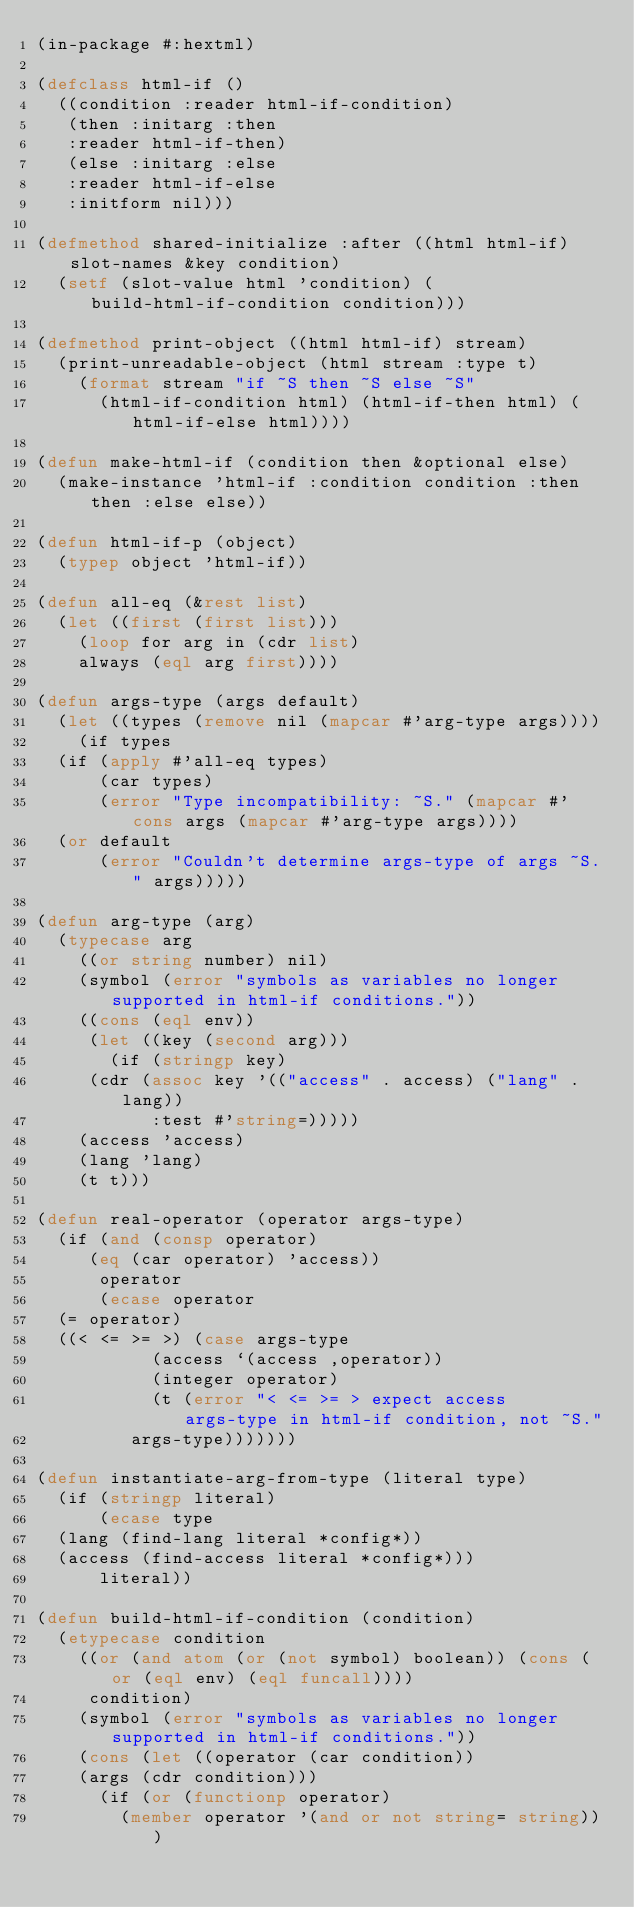<code> <loc_0><loc_0><loc_500><loc_500><_Lisp_>(in-package #:hextml)

(defclass html-if ()
  ((condition :reader html-if-condition)
   (then :initarg :then
	 :reader html-if-then)
   (else :initarg :else
	 :reader html-if-else
	 :initform nil)))

(defmethod shared-initialize :after ((html html-if) slot-names &key condition)
  (setf (slot-value html 'condition) (build-html-if-condition condition)))

(defmethod print-object ((html html-if) stream)
  (print-unreadable-object (html stream :type t)
    (format stream "if ~S then ~S else ~S"
	    (html-if-condition html) (html-if-then html) (html-if-else html))))

(defun make-html-if (condition then &optional else)
  (make-instance 'html-if :condition condition :then then :else else))

(defun html-if-p (object)
  (typep object 'html-if))

(defun all-eq (&rest list)
  (let ((first (first list)))
    (loop for arg in (cdr list)
	  always (eql arg first))))

(defun args-type (args default)
  (let ((types (remove nil (mapcar #'arg-type args))))
    (if types
	(if (apply #'all-eq types)
	    (car types)
	    (error "Type incompatibility: ~S." (mapcar #'cons args (mapcar #'arg-type args))))
	(or default
	    (error "Couldn't determine args-type of args ~S." args)))))

(defun arg-type (arg)
  (typecase arg
    ((or string number) nil)
    (symbol (error "symbols as variables no longer supported in html-if conditions."))
    ((cons (eql env))
     (let ((key (second arg)))
       (if (stringp key)
	   (cdr (assoc key '(("access" . access) ("lang" . lang))
		       :test #'string=)))))
    (access 'access)
    (lang 'lang)
    (t t)))

(defun real-operator (operator args-type)
  (if (and (consp operator)
	   (eq (car operator) 'access))
      operator
      (ecase operator
	(= operator)
	((< <= >= >) (case args-type
		       (access `(access ,operator))
		       (integer operator)
		       (t (error "< <= >= > expect access args-type in html-if condition, not ~S."
				 args-type)))))))

(defun instantiate-arg-from-type (literal type)
  (if (stringp literal)
      (ecase type
	(lang (find-lang literal *config*))
	(access (find-access literal *config*)))
      literal))

(defun build-html-if-condition (condition)
  (etypecase condition
    ((or (and atom (or (not symbol) boolean)) (cons (or (eql env) (eql funcall))))
     condition)
    (symbol (error "symbols as variables no longer supported in html-if conditions."))
    (cons (let ((operator (car condition))
		(args (cdr condition)))
	    (if (or (functionp operator)
		    (member operator '(and or not string= string)))</code> 